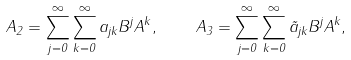<formula> <loc_0><loc_0><loc_500><loc_500>A _ { 2 } = \sum _ { j = 0 } ^ { \infty } \sum _ { k = 0 } ^ { \infty } a _ { j k } B ^ { j } A ^ { k } , \quad A _ { 3 } = \sum _ { j = 0 } ^ { \infty } \sum _ { k = 0 } ^ { \infty } \tilde { a } _ { j k } B ^ { j } A ^ { k } ,</formula> 